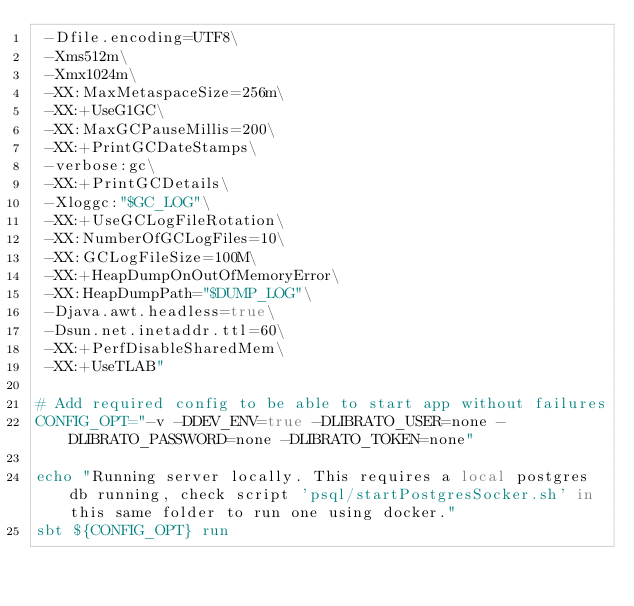<code> <loc_0><loc_0><loc_500><loc_500><_Bash_> -Dfile.encoding=UTF8\
 -Xms512m\
 -Xmx1024m\
 -XX:MaxMetaspaceSize=256m\
 -XX:+UseG1GC\
 -XX:MaxGCPauseMillis=200\
 -XX:+PrintGCDateStamps\
 -verbose:gc\
 -XX:+PrintGCDetails\
 -Xloggc:"$GC_LOG"\
 -XX:+UseGCLogFileRotation\
 -XX:NumberOfGCLogFiles=10\
 -XX:GCLogFileSize=100M\
 -XX:+HeapDumpOnOutOfMemoryError\
 -XX:HeapDumpPath="$DUMP_LOG"\
 -Djava.awt.headless=true\
 -Dsun.net.inetaddr.ttl=60\
 -XX:+PerfDisableSharedMem\
 -XX:+UseTLAB"

# Add required config to be able to start app without failures
CONFIG_OPT="-v -DDEV_ENV=true -DLIBRATO_USER=none -DLIBRATO_PASSWORD=none -DLIBRATO_TOKEN=none"

echo "Running server locally. This requires a local postgres db running, check script 'psql/startPostgresSocker.sh' in this same folder to run one using docker."
sbt ${CONFIG_OPT} run</code> 